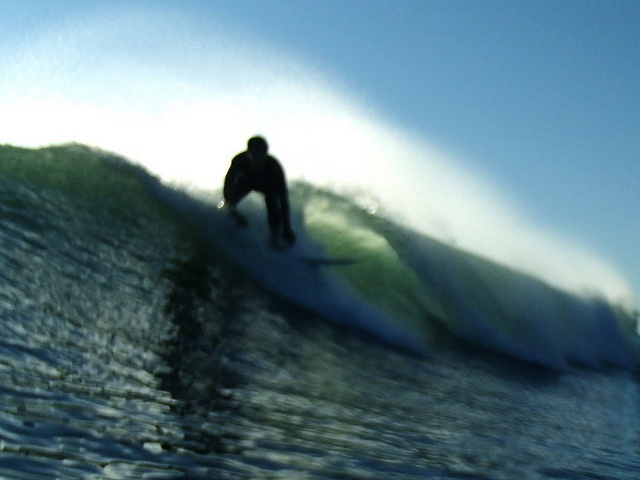Describe the objects in this image and their specific colors. I can see people in lightblue, black, teal, purple, and darkgreen tones and surfboard in lightblue, navy, darkblue, darkgreen, and teal tones in this image. 